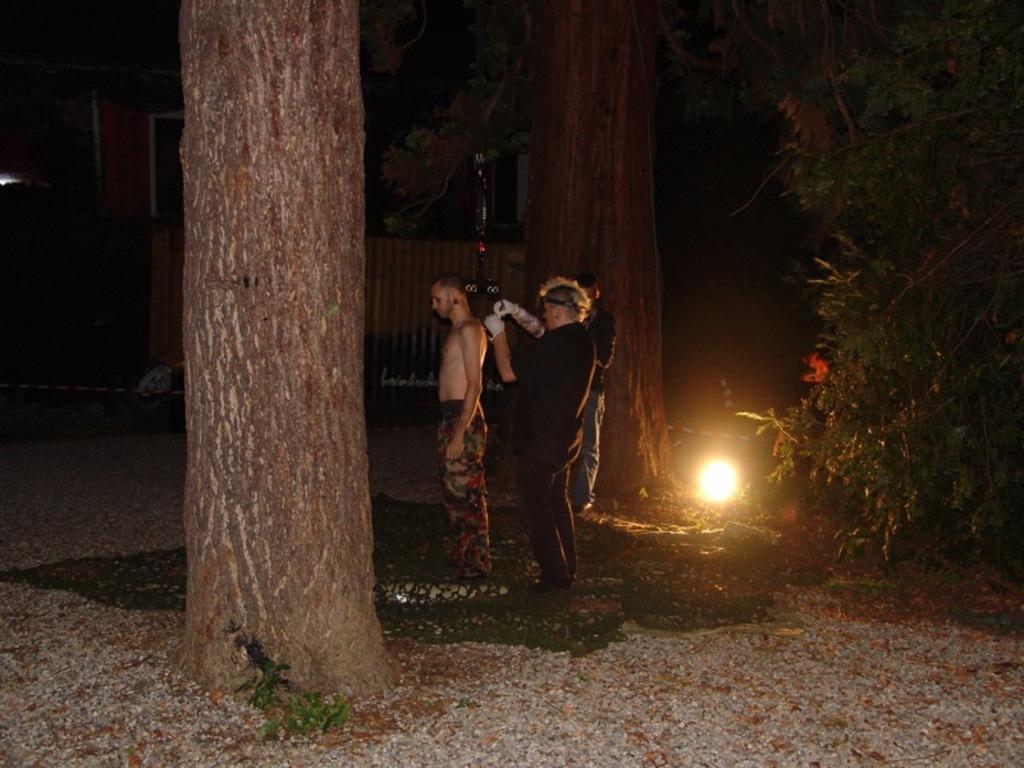How would you summarize this image in a sentence or two? In this image we can see a group of people are standing on the ground, here is the light, here are the trees. 